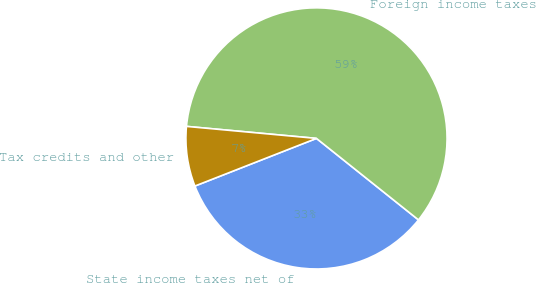<chart> <loc_0><loc_0><loc_500><loc_500><pie_chart><fcel>State income taxes net of<fcel>Foreign income taxes<fcel>Tax credits and other<nl><fcel>33.33%<fcel>59.26%<fcel>7.41%<nl></chart> 